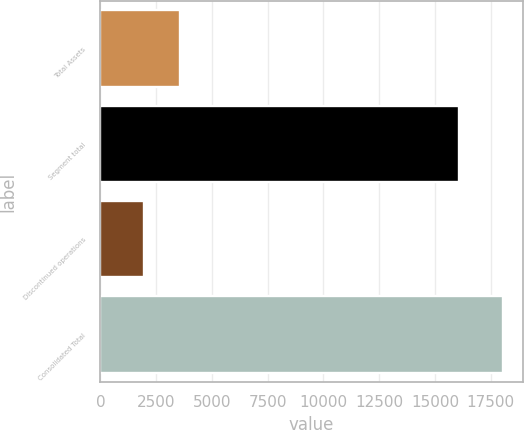<chart> <loc_0><loc_0><loc_500><loc_500><bar_chart><fcel>Total Assets<fcel>Segment total<fcel>Discontinued operations<fcel>Consolidated Total<nl><fcel>3574.51<fcel>16060.1<fcel>1968.5<fcel>18028.6<nl></chart> 